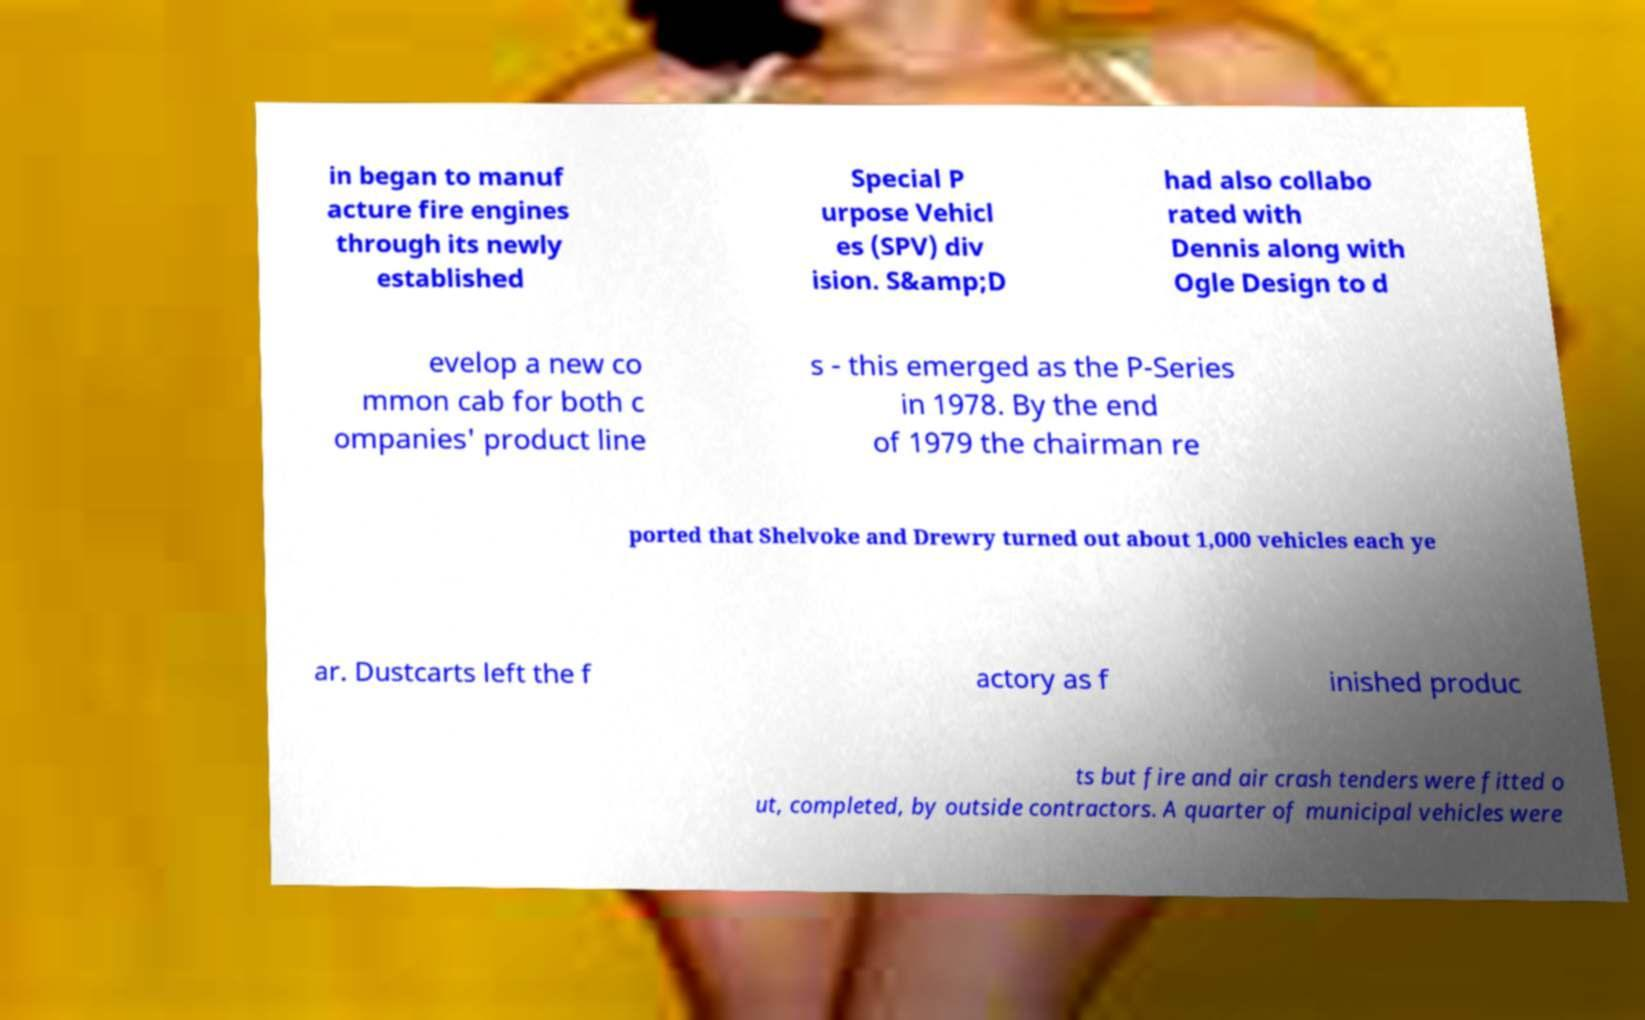Can you read and provide the text displayed in the image?This photo seems to have some interesting text. Can you extract and type it out for me? in began to manuf acture fire engines through its newly established Special P urpose Vehicl es (SPV) div ision. S&amp;D had also collabo rated with Dennis along with Ogle Design to d evelop a new co mmon cab for both c ompanies' product line s - this emerged as the P-Series in 1978. By the end of 1979 the chairman re ported that Shelvoke and Drewry turned out about 1,000 vehicles each ye ar. Dustcarts left the f actory as f inished produc ts but fire and air crash tenders were fitted o ut, completed, by outside contractors. A quarter of municipal vehicles were 